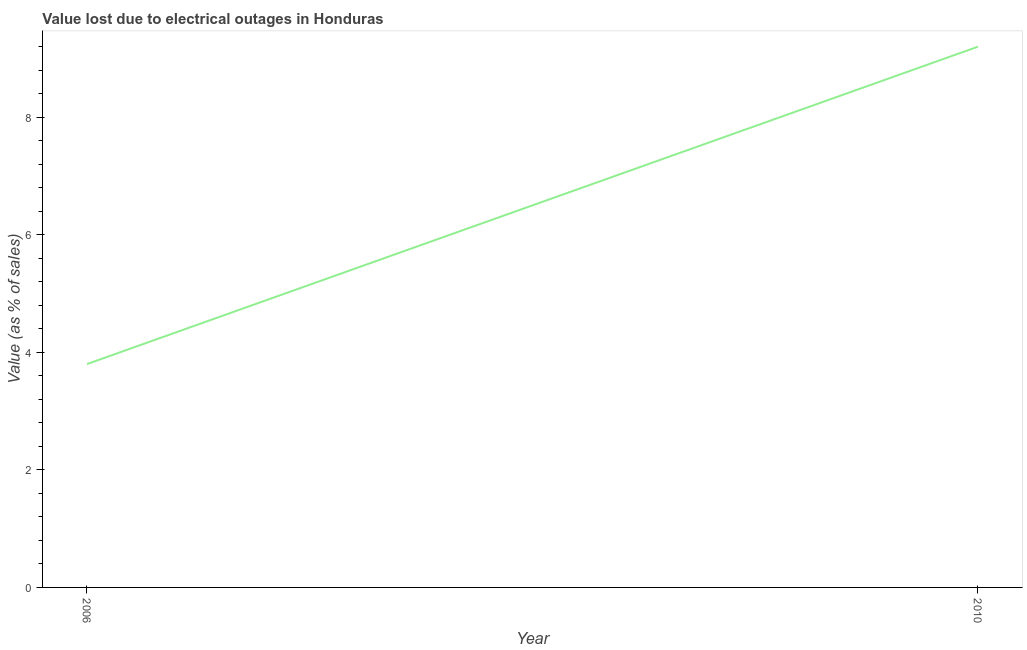Across all years, what is the minimum value lost due to electrical outages?
Offer a very short reply. 3.8. In which year was the value lost due to electrical outages maximum?
Keep it short and to the point. 2010. In which year was the value lost due to electrical outages minimum?
Your response must be concise. 2006. What is the difference between the value lost due to electrical outages in 2006 and 2010?
Offer a very short reply. -5.4. Do a majority of the years between 2010 and 2006 (inclusive) have value lost due to electrical outages greater than 8.4 %?
Your answer should be very brief. No. What is the ratio of the value lost due to electrical outages in 2006 to that in 2010?
Offer a terse response. 0.41. In how many years, is the value lost due to electrical outages greater than the average value lost due to electrical outages taken over all years?
Your response must be concise. 1. How many lines are there?
Give a very brief answer. 1. How many years are there in the graph?
Offer a terse response. 2. Does the graph contain any zero values?
Offer a very short reply. No. Does the graph contain grids?
Your response must be concise. No. What is the title of the graph?
Give a very brief answer. Value lost due to electrical outages in Honduras. What is the label or title of the Y-axis?
Provide a short and direct response. Value (as % of sales). What is the Value (as % of sales) in 2010?
Offer a terse response. 9.2. What is the difference between the Value (as % of sales) in 2006 and 2010?
Ensure brevity in your answer.  -5.4. What is the ratio of the Value (as % of sales) in 2006 to that in 2010?
Keep it short and to the point. 0.41. 